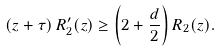Convert formula to latex. <formula><loc_0><loc_0><loc_500><loc_500>\left ( z + \tau \right ) R _ { 2 } ^ { \prime } ( z ) \geq \left ( 2 + \frac { d } { 2 } \right ) R _ { 2 } ( z ) .</formula> 